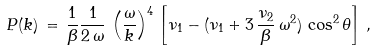Convert formula to latex. <formula><loc_0><loc_0><loc_500><loc_500>P ( k ) \, = \, \frac { 1 } { \beta } \frac { 1 } { 2 \, \omega } \, \left ( \frac { \omega } { k } \right ) ^ { 4 } \, \left [ \nu _ { 1 } - ( \nu _ { 1 } + 3 \, \frac { \nu _ { 2 } } { \beta } \, \omega ^ { 2 } ) \, \cos ^ { 2 } \theta \right ] \, ,</formula> 